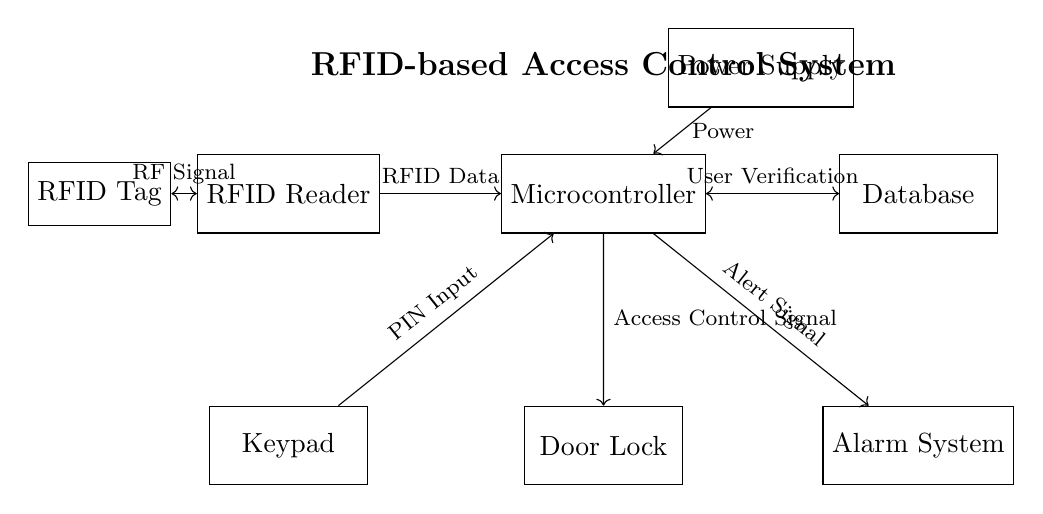What components are present in this circuit diagram? The circuit includes an RFID Reader, Microcontroller, Database, Door Lock, RFID Tag, Keypad, Alarm System, and Power Supply. Each component serves a specific function in the access control system.
Answer: RFID Reader, Microcontroller, Database, Door Lock, RFID Tag, Keypad, Alarm System, Power Supply How does the RFID Tag communicate with the RFID Reader? The RFID Tag communicates with the RFID Reader using RF Signals. This interaction allows data to be exchanged, and the RFID Reader can identify the tag accordingly.
Answer: RF Signal What type of signal is used to control the Door Lock? The microcontroller sends an Access Control Signal to the Door Lock based on the verification process of the RFID data. This signal determines whether access is granted or denied.
Answer: Access Control Signal Which component provides power to the Microcontroller? The Power Supply provides the necessary power to the Microcontroller, enabling it to function and process the information it receives.
Answer: Power Supply What role does the Keypad play in this circuit? The Keypad allows users to input a PIN, which the Microcontroller uses for additional user verification before granting access. This extra layer enhances security.
Answer: PIN Input If the RFID Reader detects an unauthorized RFID Tag, what signal is sent to the Alarm System? The Microcontroller will send an Alert Signal to the Alarm System, indicating a security breach has occurred. This system activates to inform personnel of the unauthorized access attempt.
Answer: Alert Signal How is user verification conducted in this access control system? User verification occurs through a process within the Microcontroller, which checks the RFID data against the Database and potentially uses the PIN input from the Keypad for confirmation. This ensures only authorized access.
Answer: User Verification 